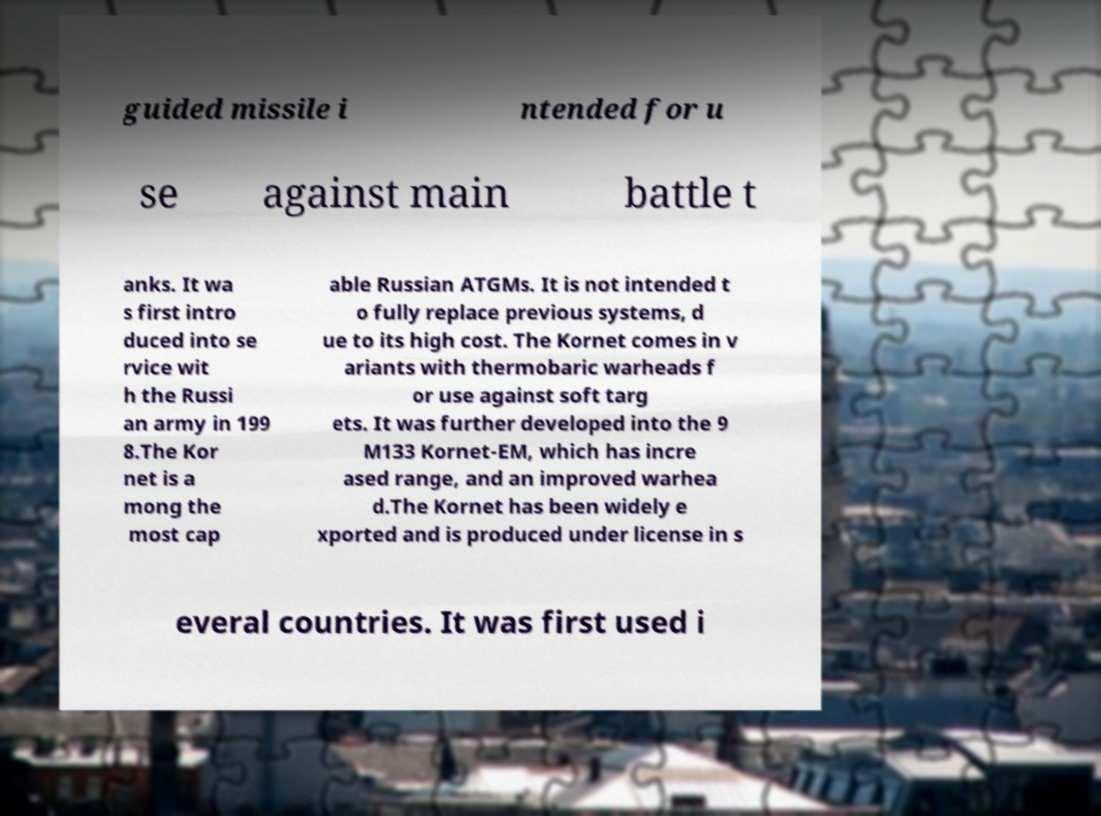There's text embedded in this image that I need extracted. Can you transcribe it verbatim? guided missile i ntended for u se against main battle t anks. It wa s first intro duced into se rvice wit h the Russi an army in 199 8.The Kor net is a mong the most cap able Russian ATGMs. It is not intended t o fully replace previous systems, d ue to its high cost. The Kornet comes in v ariants with thermobaric warheads f or use against soft targ ets. It was further developed into the 9 M133 Kornet-EM, which has incre ased range, and an improved warhea d.The Kornet has been widely e xported and is produced under license in s everal countries. It was first used i 